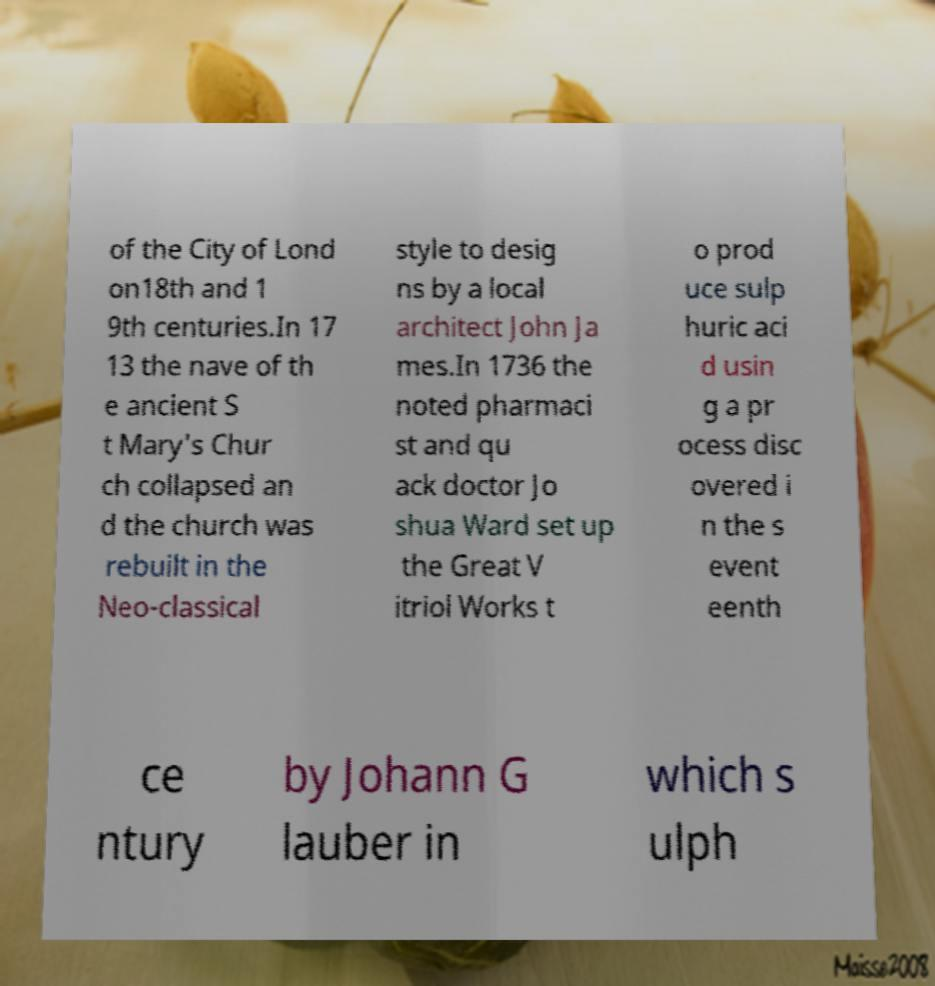There's text embedded in this image that I need extracted. Can you transcribe it verbatim? of the City of Lond on18th and 1 9th centuries.In 17 13 the nave of th e ancient S t Mary's Chur ch collapsed an d the church was rebuilt in the Neo-classical style to desig ns by a local architect John Ja mes.In 1736 the noted pharmaci st and qu ack doctor Jo shua Ward set up the Great V itriol Works t o prod uce sulp huric aci d usin g a pr ocess disc overed i n the s event eenth ce ntury by Johann G lauber in which s ulph 